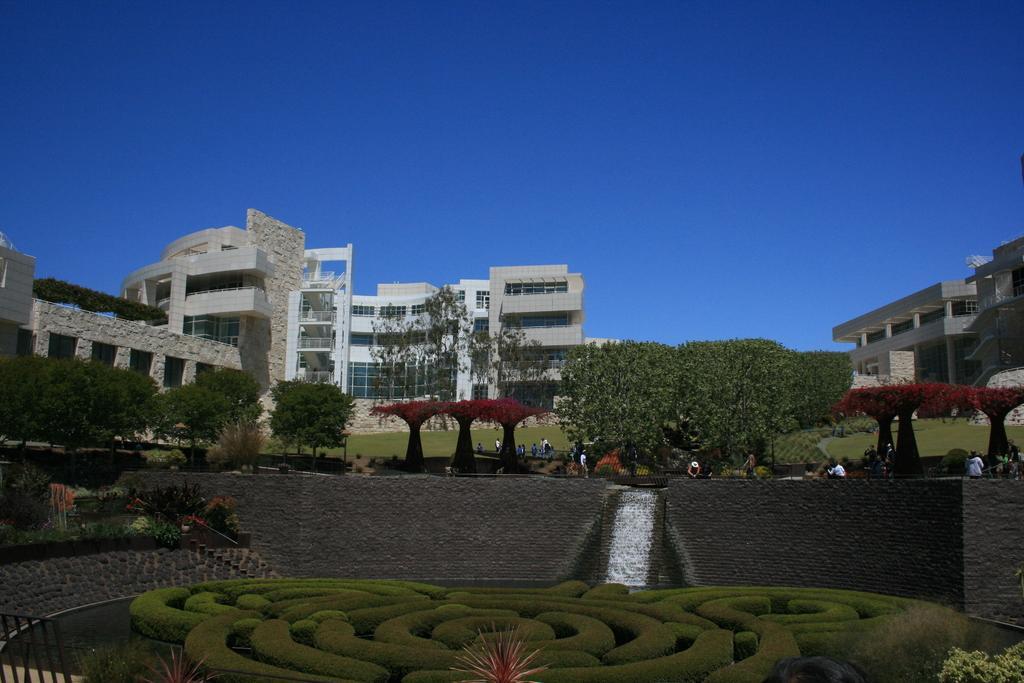Could you give a brief overview of what you see in this image? In this picture there is a beautiful house with glass windows. On the left side there is a granite wall. In the front we can see some trees and on the bottom side there is a decorative grass plants. On the right side there is a another house. 